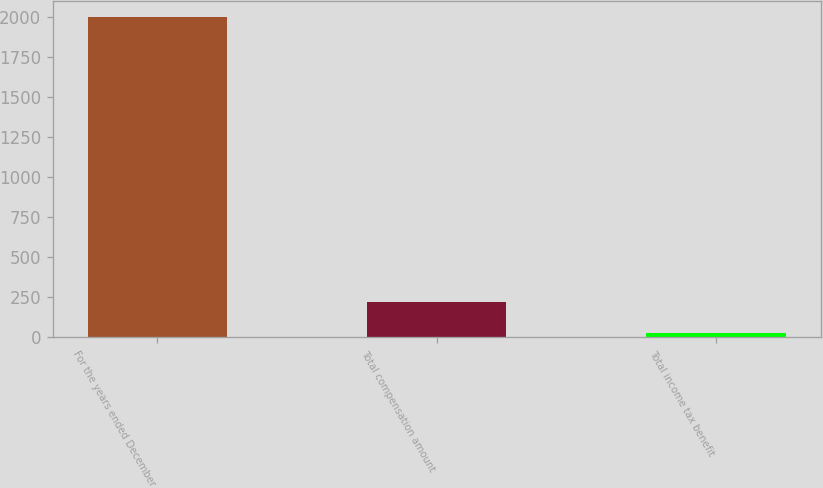<chart> <loc_0><loc_0><loc_500><loc_500><bar_chart><fcel>For the years ended December<fcel>Total compensation amount<fcel>Total income tax benefit<nl><fcel>2005<fcel>219.67<fcel>21.3<nl></chart> 